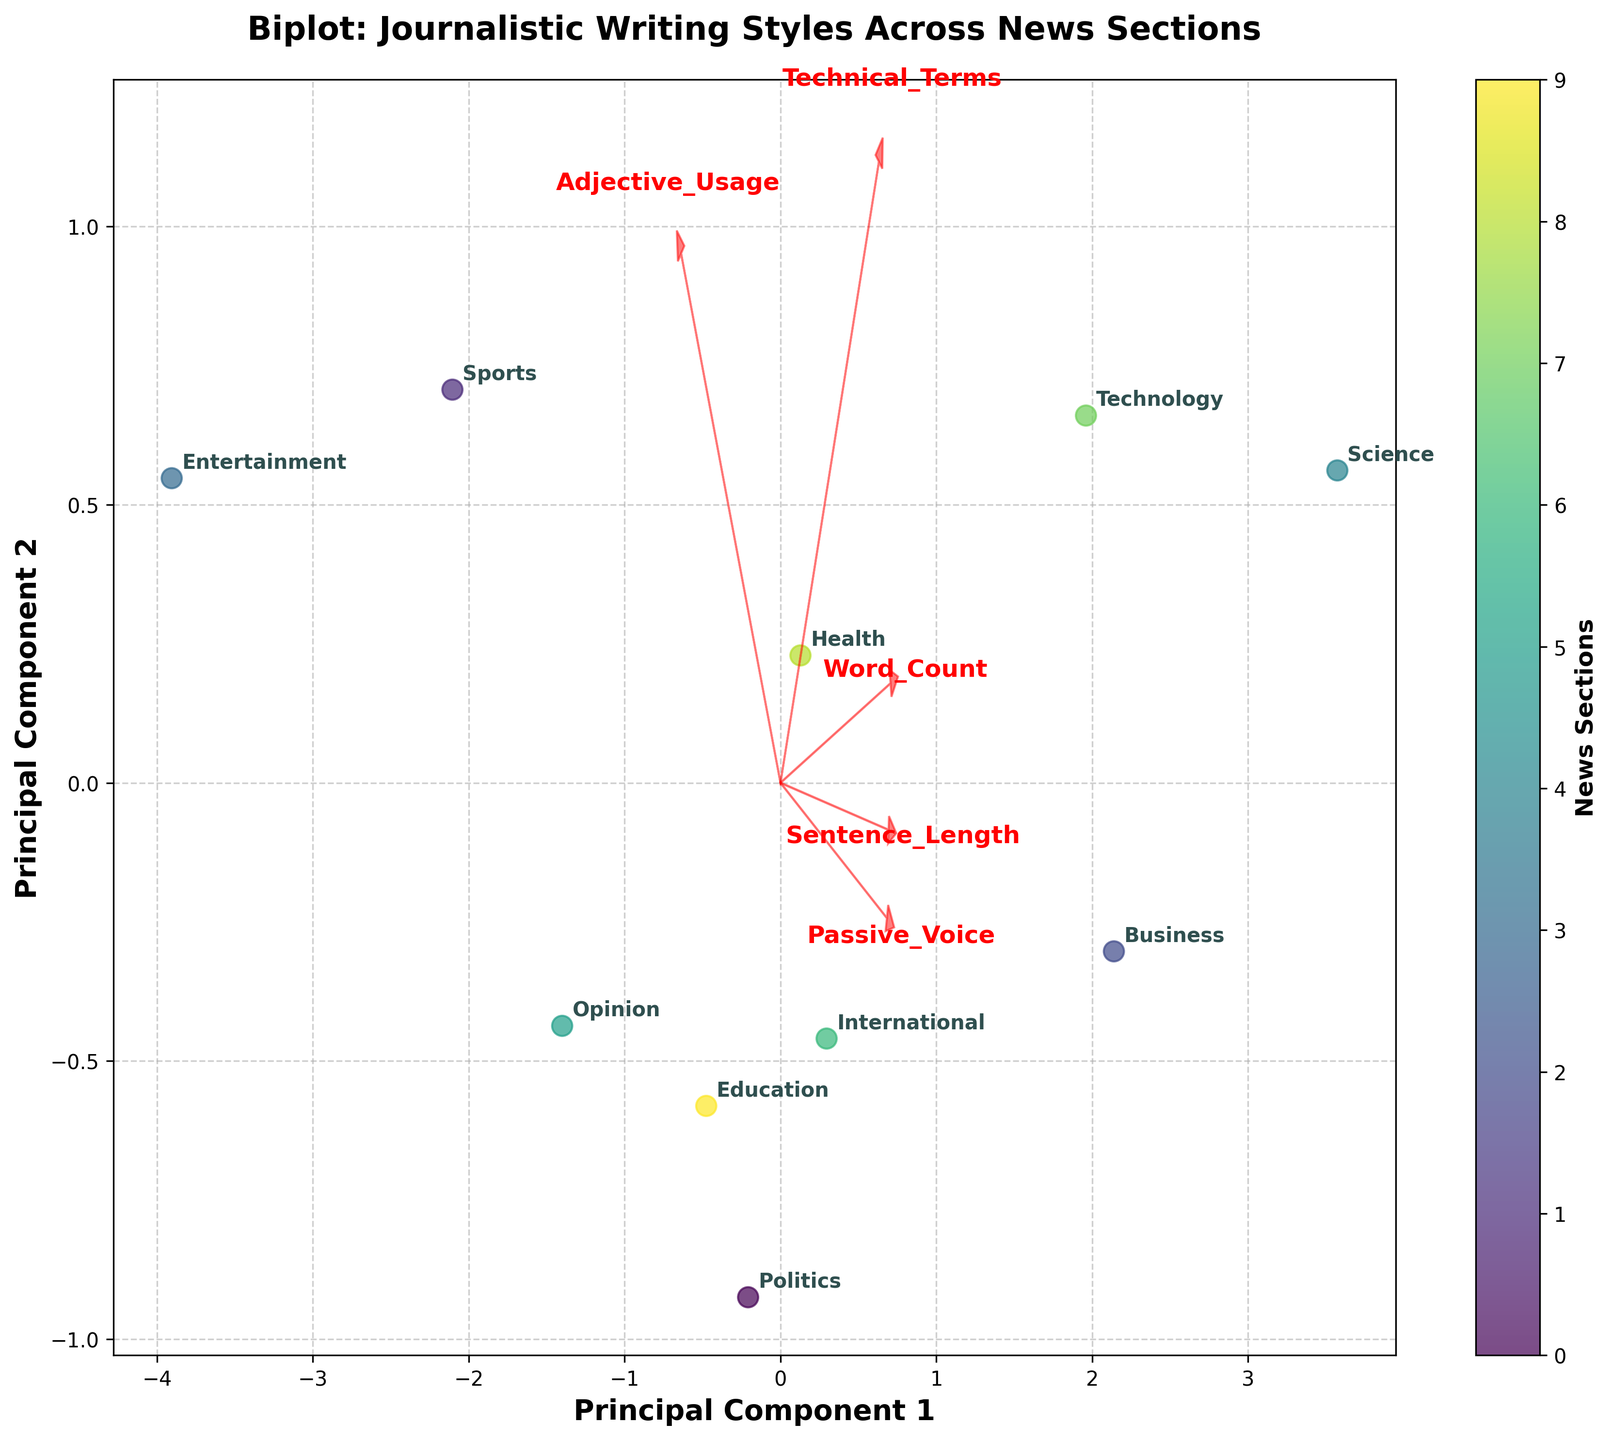What is the title of the figure? The title of the figure is typically found at the top of the chart and is usually displayed in a larger, bold font. In this case, the title is "Biplot: Journalistic Writing Styles Across News Sections".
Answer: Biplot: Journalistic Writing Styles Across News Sections How many categories of news sections are represented in the figure? The categories of news sections are labeled next to the data points on the plot. Counting these labels will give us the number of categories. In this case, there are 10 categories.
Answer: 10 Which news section uses the most adjectives, based on the direction of the 'Adjective_Usage' vector? The 'Adjective_Usage' vector is represented by an arrow labeled "Adjective_Usage". By looking at which data point lies furthest in the direction of this arrow, we can determine the section that uses the most adjectives. The "Entertainment" section lies furthest in this direction.
Answer: Entertainment Which news section has the longest average sentence length, and how can you tell? The 'Sentence_Length' vector points in the direction of increasing sentence length. The "Science" section is the furthest in the direction of this vector, indicating it has the longest average sentence length.
Answer: Science Is there any section that uses a high amount of both technical terms and passive voice? We look at the directions of the 'Technical_Terms' and 'Passive_Voice' vectors. The "Science" section is furthest in both these directions, indicating it uses a high amount of both technical terms and passive voice.
Answer: Science Between the "Technology" and "Business" sections, which one has a higher average word count? We look at the 'Word_Count' vector and compare the positions of "Technology" and "Business" along this direction. "Business" is further in the direction of the 'Word_Count' vector, indicating it has a higher average word count.
Answer: Business What can you infer about the "Opinion" section regarding adjective usage and passive voice? The position of the "Opinion" section should be analyzed relative to the vectors for 'Adjective_Usage' and 'Passive_Voice'. It is relatively well-aligned with the 'Adjective_Usage' vector and not very close to the 'Passive_Voice' vector, indicating it uses a considerable number of adjectives but not much passive voice.
Answer: High adjective usage, low passive voice Which sections are the most distinct in their writing styles based on the biplot? Look for sections that are furthest apart on the plot. "Science" and "Entertainment" are far apart, suggesting they have the most distinct writing styles.
Answer: Science and Entertainment What does the length and direction of the 'Technical_Terms' vector indicate? The length and direction of the vector indicate the strength and direction of the correlation. A longer vector means a stronger correlation, and the direction shows the increase. The 'Technical_Terms' vector is long and points in the direction where scientific and technological content lies, indicating these have high technical term usage.
Answer: Strong correlation, high technical term usage in Science and Technology How does the 'Sports' section compare to others in terms of average sentence length? We can look at the position of the "Sports" section relative to the 'Sentence_Length' vector. "Sports" is positioned closer to the origin and opposite the vector's direction for 'Sentence_Length', indicating it has one of the shortest average sentence lengths among the sections.
Answer: Shorter average sentence length 